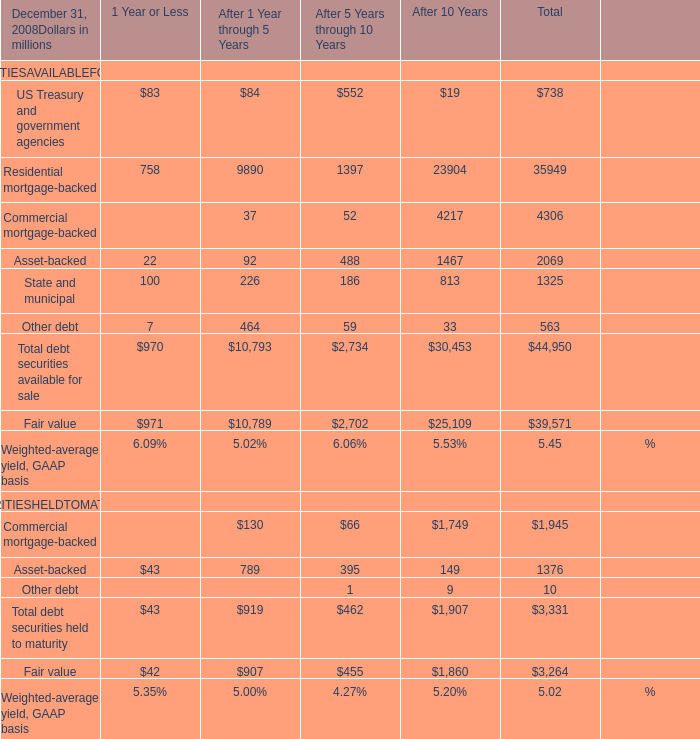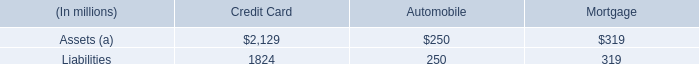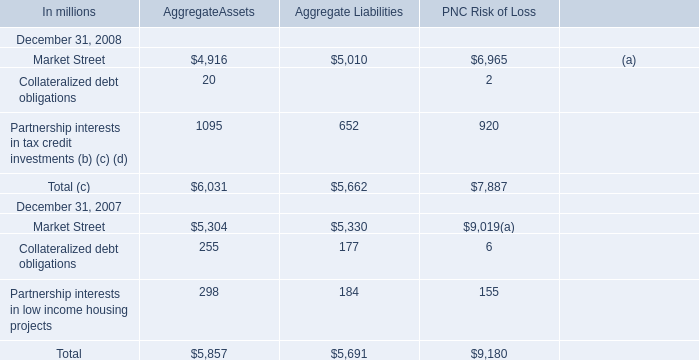What's the average of US Treasury and government agencies in 2008? 
Computations: ((((83 + 84) + 552) + 19) / 4)
Answer: 184.5. 